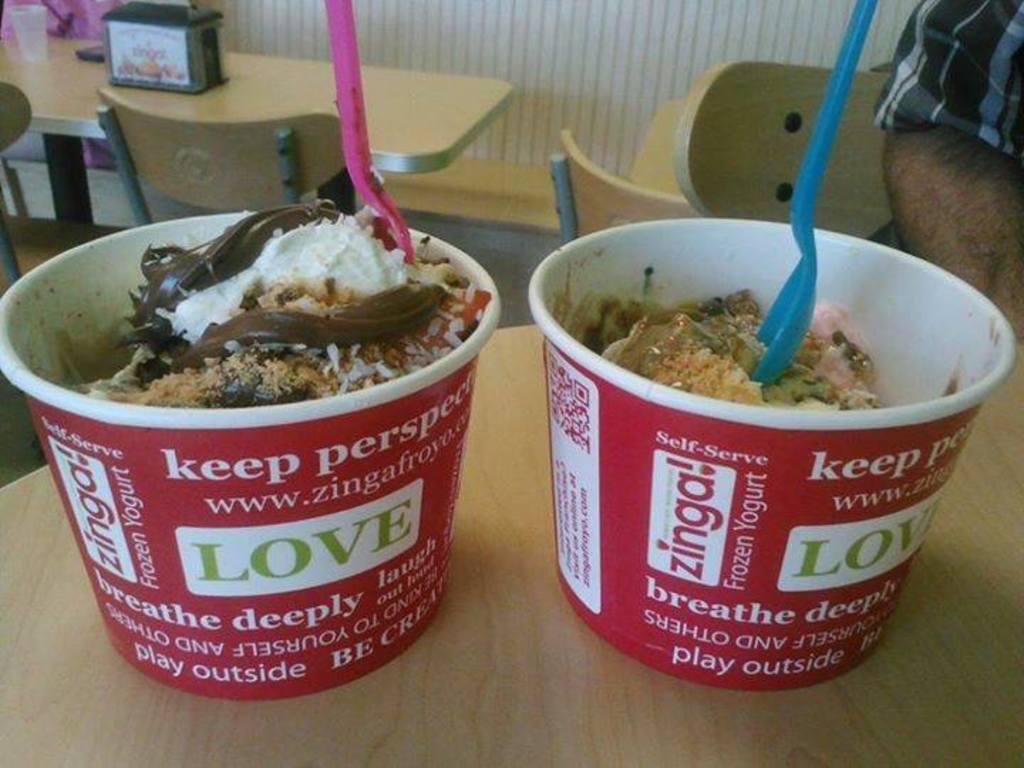What type of food is in the disposable containers in the image? There are dessert places in disposable containers in the image. Where are the dessert places located? The dessert places are placed on a table. What can be seen in the background of the image? There are tables, chairs, a tumbler, and a wall in the background of the image. What is the chance of winning a prize at the dessert party in the image? There is no mention of a dessert party or any prizes in the image, so it is not possible to determine the chance of winning a prize. 